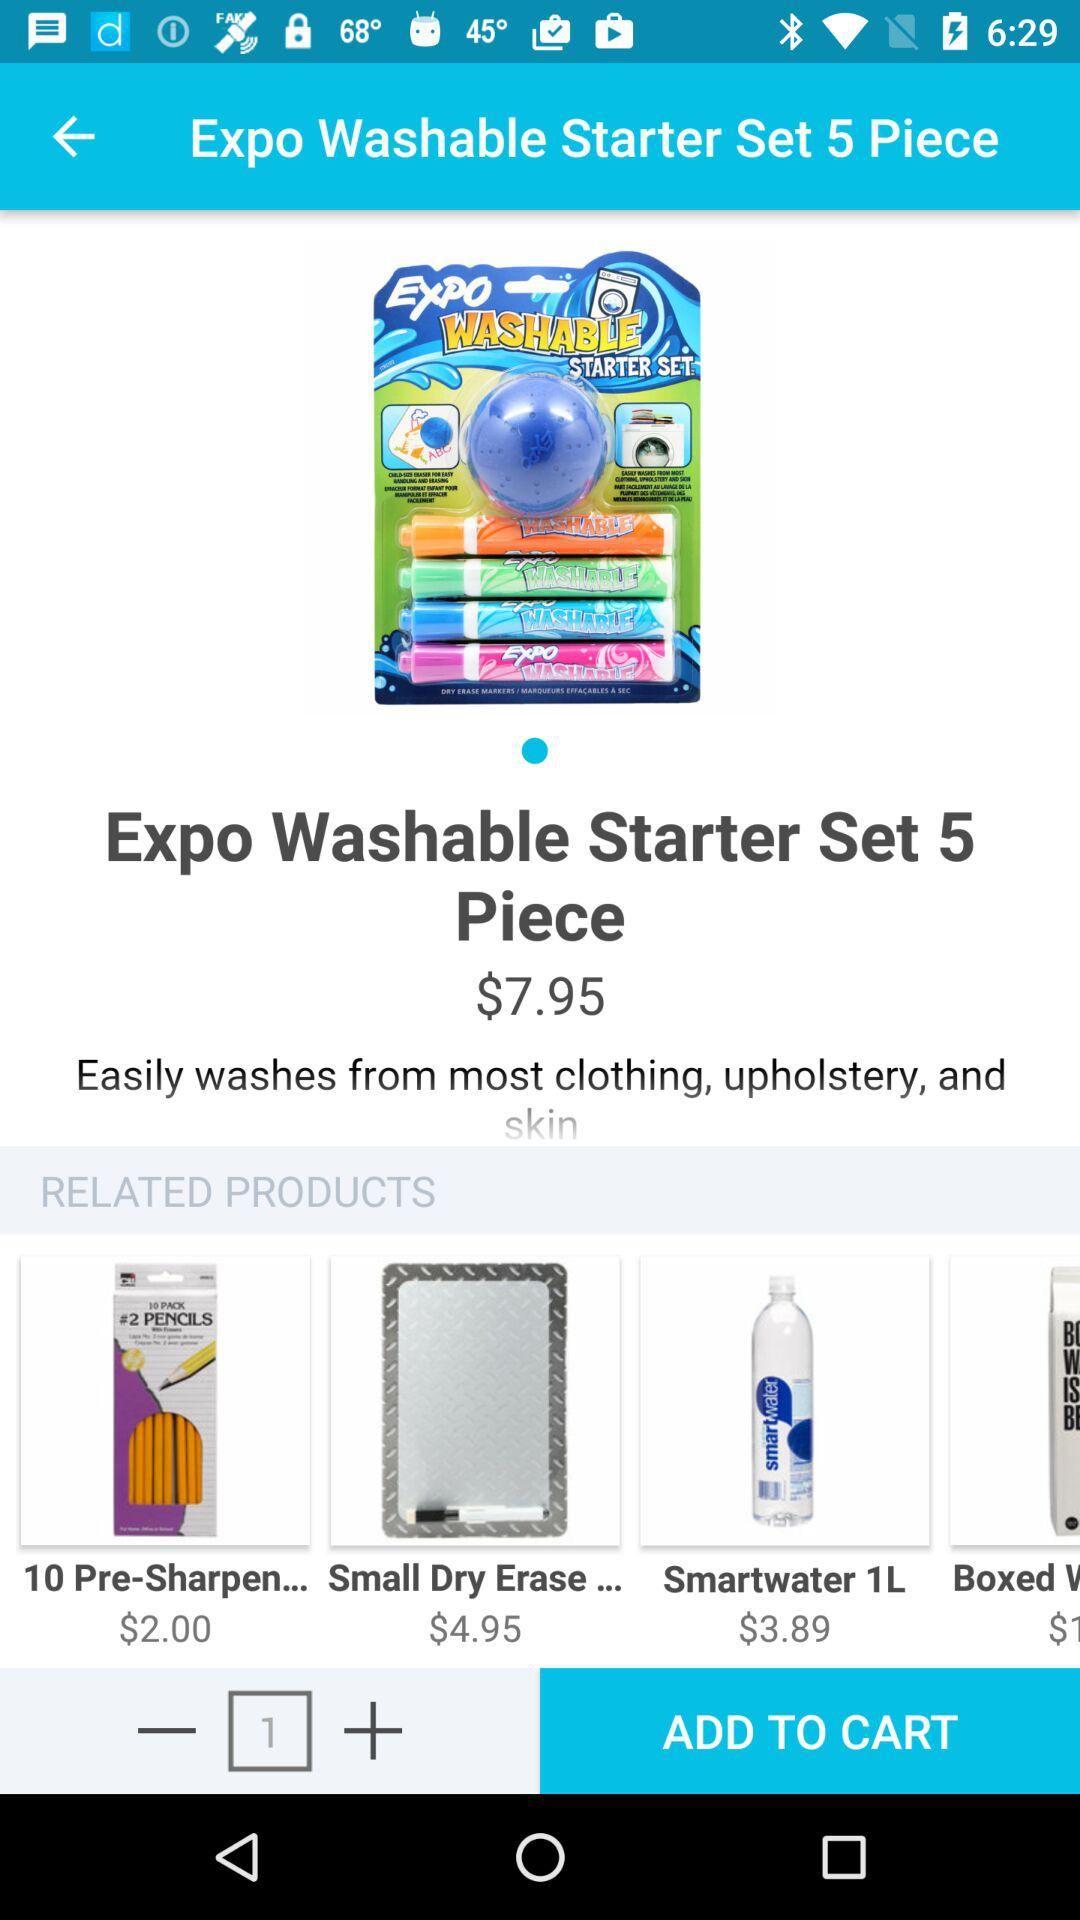How many items are there in the cart to be added? There is 1 item in the cart that is to be added. 